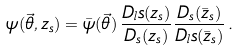<formula> <loc_0><loc_0><loc_500><loc_500>\psi ( \vec { \theta } , z _ { s } ) = \bar { \psi } ( \vec { \theta } ) \, \frac { D _ { l } s ( z _ { s } ) } { D _ { s } ( z _ { s } ) } \frac { D _ { s } ( \bar { z } _ { s } ) } { D _ { l } s ( \bar { z } _ { s } ) } \, .</formula> 